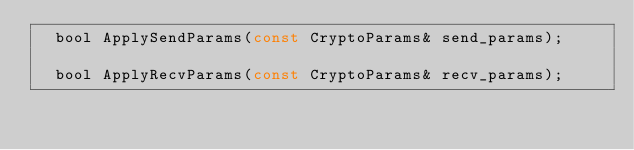Convert code to text. <code><loc_0><loc_0><loc_500><loc_500><_C_>  bool ApplySendParams(const CryptoParams& send_params);

  bool ApplyRecvParams(const CryptoParams& recv_params);
</code> 